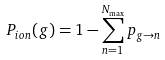Convert formula to latex. <formula><loc_0><loc_0><loc_500><loc_500>P _ { i o n } ( g ) = 1 - \sum ^ { N _ { \max } } _ { n = 1 } p _ { g \rightarrow n }</formula> 